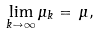Convert formula to latex. <formula><loc_0><loc_0><loc_500><loc_500>\lim _ { k \to \infty } \mu _ { k } = \, \mu ,</formula> 